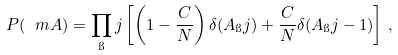Convert formula to latex. <formula><loc_0><loc_0><loc_500><loc_500>P ( \ m A ) = \prod _ { \i } j \left [ \left ( 1 - \frac { C } { N } \right ) \delta ( A _ { \i } j ) + \frac { C } { N } \delta ( A _ { \i } j - 1 ) \right ] \, ,</formula> 